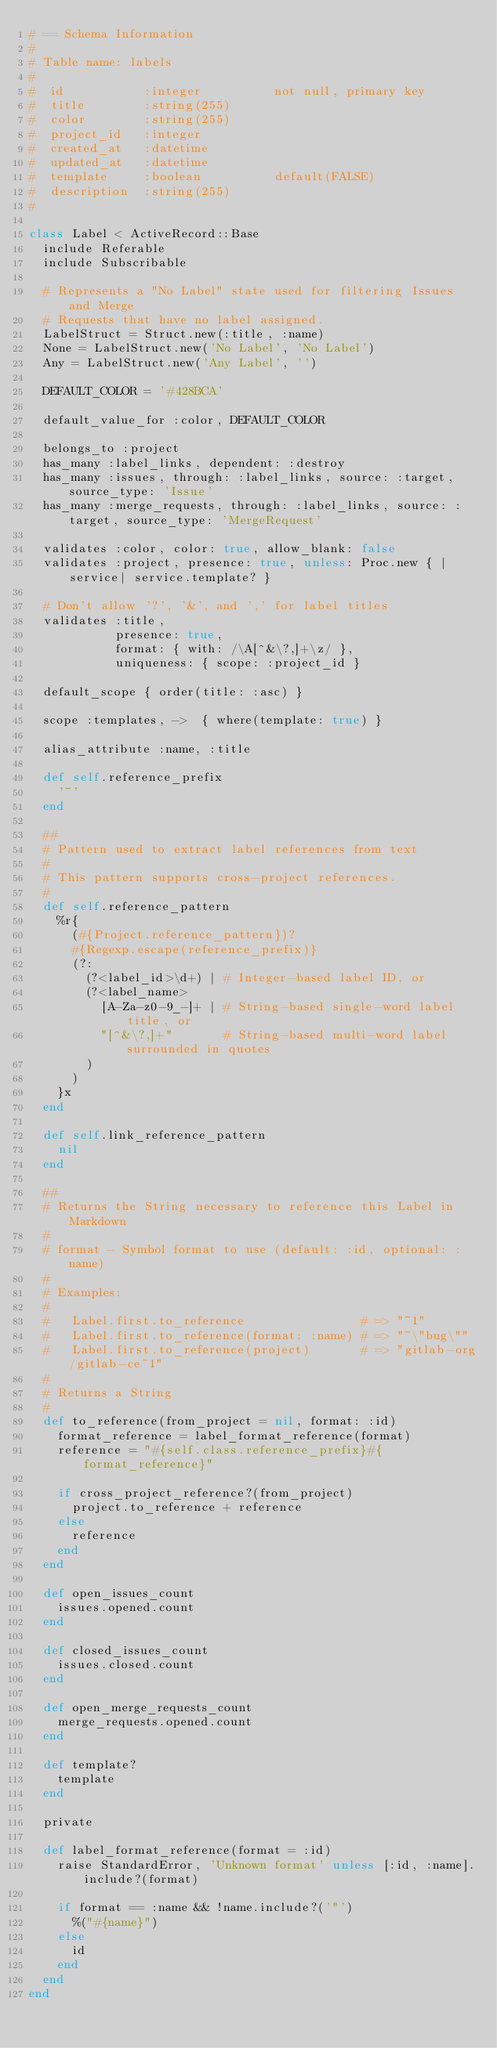Convert code to text. <code><loc_0><loc_0><loc_500><loc_500><_Ruby_># == Schema Information
#
# Table name: labels
#
#  id           :integer          not null, primary key
#  title        :string(255)
#  color        :string(255)
#  project_id   :integer
#  created_at   :datetime
#  updated_at   :datetime
#  template     :boolean          default(FALSE)
#  description  :string(255)
#

class Label < ActiveRecord::Base
  include Referable
  include Subscribable

  # Represents a "No Label" state used for filtering Issues and Merge
  # Requests that have no label assigned.
  LabelStruct = Struct.new(:title, :name)
  None = LabelStruct.new('No Label', 'No Label')
  Any = LabelStruct.new('Any Label', '')

  DEFAULT_COLOR = '#428BCA'

  default_value_for :color, DEFAULT_COLOR

  belongs_to :project
  has_many :label_links, dependent: :destroy
  has_many :issues, through: :label_links, source: :target, source_type: 'Issue'
  has_many :merge_requests, through: :label_links, source: :target, source_type: 'MergeRequest'

  validates :color, color: true, allow_blank: false
  validates :project, presence: true, unless: Proc.new { |service| service.template? }

  # Don't allow '?', '&', and ',' for label titles
  validates :title,
            presence: true,
            format: { with: /\A[^&\?,]+\z/ },
            uniqueness: { scope: :project_id }

  default_scope { order(title: :asc) }

  scope :templates, ->  { where(template: true) }

  alias_attribute :name, :title

  def self.reference_prefix
    '~'
  end

  ##
  # Pattern used to extract label references from text
  #
  # This pattern supports cross-project references.
  #
  def self.reference_pattern
    %r{
      (#{Project.reference_pattern})?
      #{Regexp.escape(reference_prefix)}
      (?:
        (?<label_id>\d+) | # Integer-based label ID, or
        (?<label_name>
          [A-Za-z0-9_-]+ | # String-based single-word label title, or
          "[^&\?,]+"       # String-based multi-word label surrounded in quotes
        )
      )
    }x
  end

  def self.link_reference_pattern
    nil
  end

  ##
  # Returns the String necessary to reference this Label in Markdown
  #
  # format - Symbol format to use (default: :id, optional: :name)
  #
  # Examples:
  #
  #   Label.first.to_reference                # => "~1"
  #   Label.first.to_reference(format: :name) # => "~\"bug\""
  #   Label.first.to_reference(project)       # => "gitlab-org/gitlab-ce~1"
  #
  # Returns a String
  #
  def to_reference(from_project = nil, format: :id)
    format_reference = label_format_reference(format)
    reference = "#{self.class.reference_prefix}#{format_reference}"

    if cross_project_reference?(from_project)
      project.to_reference + reference
    else
      reference
    end
  end

  def open_issues_count
    issues.opened.count
  end

  def closed_issues_count
    issues.closed.count
  end

  def open_merge_requests_count
    merge_requests.opened.count
  end

  def template?
    template
  end

  private

  def label_format_reference(format = :id)
    raise StandardError, 'Unknown format' unless [:id, :name].include?(format)

    if format == :name && !name.include?('"')
      %("#{name}")
    else
      id
    end
  end
end
</code> 